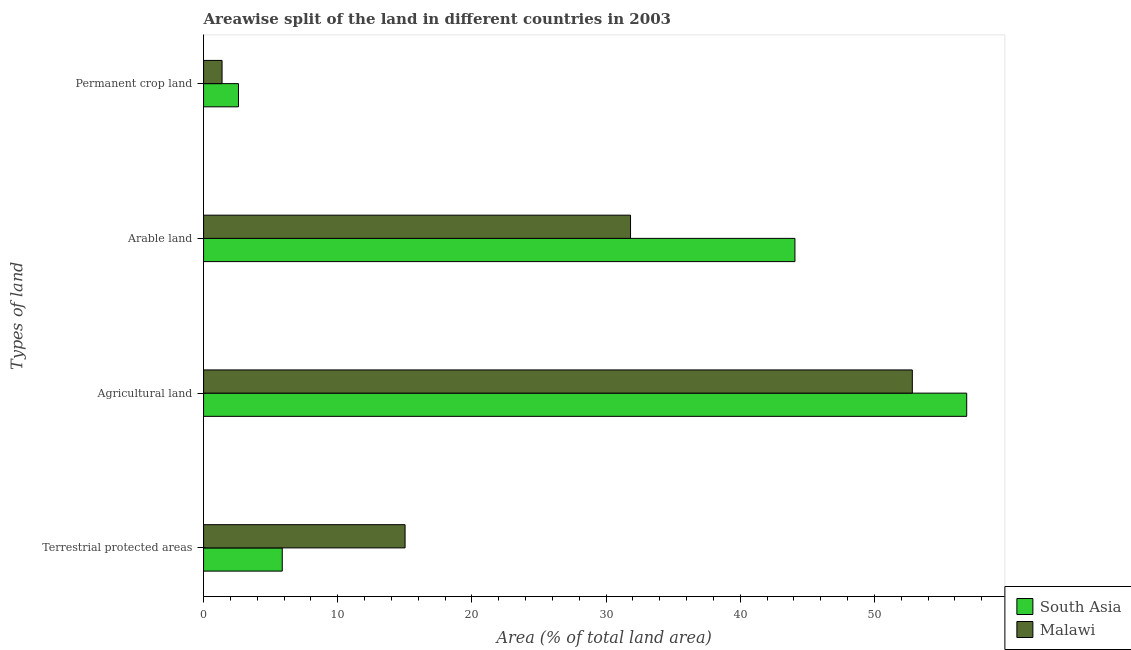How many groups of bars are there?
Ensure brevity in your answer.  4. Are the number of bars on each tick of the Y-axis equal?
Provide a short and direct response. Yes. How many bars are there on the 4th tick from the bottom?
Provide a short and direct response. 2. What is the label of the 3rd group of bars from the top?
Provide a short and direct response. Agricultural land. What is the percentage of area under agricultural land in Malawi?
Ensure brevity in your answer.  52.82. Across all countries, what is the maximum percentage of area under agricultural land?
Offer a terse response. 56.87. Across all countries, what is the minimum percentage of area under agricultural land?
Your answer should be compact. 52.82. In which country was the percentage of area under permanent crop land maximum?
Keep it short and to the point. South Asia. What is the total percentage of area under arable land in the graph?
Offer a very short reply. 75.89. What is the difference between the percentage of area under permanent crop land in Malawi and that in South Asia?
Your response must be concise. -1.22. What is the difference between the percentage of area under permanent crop land in Malawi and the percentage of land under terrestrial protection in South Asia?
Give a very brief answer. -4.49. What is the average percentage of land under terrestrial protection per country?
Ensure brevity in your answer.  10.44. What is the difference between the percentage of area under arable land and percentage of area under permanent crop land in South Asia?
Offer a very short reply. 41.47. What is the ratio of the percentage of area under agricultural land in South Asia to that in Malawi?
Provide a succinct answer. 1.08. Is the percentage of area under arable land in Malawi less than that in South Asia?
Provide a short and direct response. Yes. Is the difference between the percentage of area under permanent crop land in Malawi and South Asia greater than the difference between the percentage of area under arable land in Malawi and South Asia?
Make the answer very short. Yes. What is the difference between the highest and the second highest percentage of area under agricultural land?
Ensure brevity in your answer.  4.05. What is the difference between the highest and the lowest percentage of land under terrestrial protection?
Ensure brevity in your answer.  9.15. In how many countries, is the percentage of area under permanent crop land greater than the average percentage of area under permanent crop land taken over all countries?
Keep it short and to the point. 1. Is the sum of the percentage of area under agricultural land in South Asia and Malawi greater than the maximum percentage of land under terrestrial protection across all countries?
Your response must be concise. Yes. Does the graph contain any zero values?
Your response must be concise. No. Does the graph contain grids?
Provide a succinct answer. No. Where does the legend appear in the graph?
Ensure brevity in your answer.  Bottom right. How many legend labels are there?
Keep it short and to the point. 2. How are the legend labels stacked?
Give a very brief answer. Vertical. What is the title of the graph?
Your answer should be very brief. Areawise split of the land in different countries in 2003. What is the label or title of the X-axis?
Make the answer very short. Area (% of total land area). What is the label or title of the Y-axis?
Offer a terse response. Types of land. What is the Area (% of total land area) in South Asia in Terrestrial protected areas?
Ensure brevity in your answer.  5.87. What is the Area (% of total land area) of Malawi in Terrestrial protected areas?
Keep it short and to the point. 15.02. What is the Area (% of total land area) of South Asia in Agricultural land?
Make the answer very short. 56.87. What is the Area (% of total land area) in Malawi in Agricultural land?
Give a very brief answer. 52.82. What is the Area (% of total land area) of South Asia in Arable land?
Provide a succinct answer. 44.07. What is the Area (% of total land area) of Malawi in Arable land?
Your response must be concise. 31.82. What is the Area (% of total land area) in South Asia in Permanent crop land?
Your answer should be very brief. 2.6. What is the Area (% of total land area) of Malawi in Permanent crop land?
Offer a very short reply. 1.38. Across all Types of land, what is the maximum Area (% of total land area) of South Asia?
Your answer should be compact. 56.87. Across all Types of land, what is the maximum Area (% of total land area) of Malawi?
Keep it short and to the point. 52.82. Across all Types of land, what is the minimum Area (% of total land area) of South Asia?
Give a very brief answer. 2.6. Across all Types of land, what is the minimum Area (% of total land area) of Malawi?
Give a very brief answer. 1.38. What is the total Area (% of total land area) in South Asia in the graph?
Your answer should be very brief. 109.41. What is the total Area (% of total land area) in Malawi in the graph?
Provide a short and direct response. 101.04. What is the difference between the Area (% of total land area) of South Asia in Terrestrial protected areas and that in Agricultural land?
Make the answer very short. -51.01. What is the difference between the Area (% of total land area) in Malawi in Terrestrial protected areas and that in Agricultural land?
Your response must be concise. -37.8. What is the difference between the Area (% of total land area) of South Asia in Terrestrial protected areas and that in Arable land?
Your answer should be very brief. -38.21. What is the difference between the Area (% of total land area) of Malawi in Terrestrial protected areas and that in Arable land?
Provide a succinct answer. -16.8. What is the difference between the Area (% of total land area) of South Asia in Terrestrial protected areas and that in Permanent crop land?
Offer a terse response. 3.26. What is the difference between the Area (% of total land area) in Malawi in Terrestrial protected areas and that in Permanent crop land?
Keep it short and to the point. 13.64. What is the difference between the Area (% of total land area) in South Asia in Agricultural land and that in Arable land?
Keep it short and to the point. 12.8. What is the difference between the Area (% of total land area) in Malawi in Agricultural land and that in Arable land?
Ensure brevity in your answer.  21. What is the difference between the Area (% of total land area) of South Asia in Agricultural land and that in Permanent crop land?
Provide a short and direct response. 54.27. What is the difference between the Area (% of total land area) of Malawi in Agricultural land and that in Permanent crop land?
Your answer should be very brief. 51.44. What is the difference between the Area (% of total land area) of South Asia in Arable land and that in Permanent crop land?
Offer a very short reply. 41.47. What is the difference between the Area (% of total land area) in Malawi in Arable land and that in Permanent crop land?
Your response must be concise. 30.44. What is the difference between the Area (% of total land area) in South Asia in Terrestrial protected areas and the Area (% of total land area) in Malawi in Agricultural land?
Keep it short and to the point. -46.96. What is the difference between the Area (% of total land area) of South Asia in Terrestrial protected areas and the Area (% of total land area) of Malawi in Arable land?
Your answer should be very brief. -25.95. What is the difference between the Area (% of total land area) of South Asia in Terrestrial protected areas and the Area (% of total land area) of Malawi in Permanent crop land?
Provide a short and direct response. 4.49. What is the difference between the Area (% of total land area) in South Asia in Agricultural land and the Area (% of total land area) in Malawi in Arable land?
Make the answer very short. 25.05. What is the difference between the Area (% of total land area) of South Asia in Agricultural land and the Area (% of total land area) of Malawi in Permanent crop land?
Your answer should be compact. 55.5. What is the difference between the Area (% of total land area) in South Asia in Arable land and the Area (% of total land area) in Malawi in Permanent crop land?
Your answer should be compact. 42.69. What is the average Area (% of total land area) in South Asia per Types of land?
Provide a short and direct response. 27.35. What is the average Area (% of total land area) in Malawi per Types of land?
Provide a short and direct response. 25.26. What is the difference between the Area (% of total land area) in South Asia and Area (% of total land area) in Malawi in Terrestrial protected areas?
Your answer should be very brief. -9.15. What is the difference between the Area (% of total land area) in South Asia and Area (% of total land area) in Malawi in Agricultural land?
Offer a terse response. 4.05. What is the difference between the Area (% of total land area) in South Asia and Area (% of total land area) in Malawi in Arable land?
Your response must be concise. 12.25. What is the difference between the Area (% of total land area) of South Asia and Area (% of total land area) of Malawi in Permanent crop land?
Provide a succinct answer. 1.22. What is the ratio of the Area (% of total land area) in South Asia in Terrestrial protected areas to that in Agricultural land?
Provide a succinct answer. 0.1. What is the ratio of the Area (% of total land area) of Malawi in Terrestrial protected areas to that in Agricultural land?
Your response must be concise. 0.28. What is the ratio of the Area (% of total land area) in South Asia in Terrestrial protected areas to that in Arable land?
Provide a short and direct response. 0.13. What is the ratio of the Area (% of total land area) of Malawi in Terrestrial protected areas to that in Arable land?
Give a very brief answer. 0.47. What is the ratio of the Area (% of total land area) in South Asia in Terrestrial protected areas to that in Permanent crop land?
Ensure brevity in your answer.  2.25. What is the ratio of the Area (% of total land area) of Malawi in Terrestrial protected areas to that in Permanent crop land?
Make the answer very short. 10.89. What is the ratio of the Area (% of total land area) of South Asia in Agricultural land to that in Arable land?
Make the answer very short. 1.29. What is the ratio of the Area (% of total land area) in Malawi in Agricultural land to that in Arable land?
Give a very brief answer. 1.66. What is the ratio of the Area (% of total land area) in South Asia in Agricultural land to that in Permanent crop land?
Make the answer very short. 21.85. What is the ratio of the Area (% of total land area) of Malawi in Agricultural land to that in Permanent crop land?
Provide a short and direct response. 38.31. What is the ratio of the Area (% of total land area) of South Asia in Arable land to that in Permanent crop land?
Provide a short and direct response. 16.94. What is the ratio of the Area (% of total land area) in Malawi in Arable land to that in Permanent crop land?
Offer a very short reply. 23.08. What is the difference between the highest and the second highest Area (% of total land area) of South Asia?
Provide a short and direct response. 12.8. What is the difference between the highest and the second highest Area (% of total land area) of Malawi?
Offer a very short reply. 21. What is the difference between the highest and the lowest Area (% of total land area) of South Asia?
Offer a very short reply. 54.27. What is the difference between the highest and the lowest Area (% of total land area) in Malawi?
Provide a short and direct response. 51.44. 